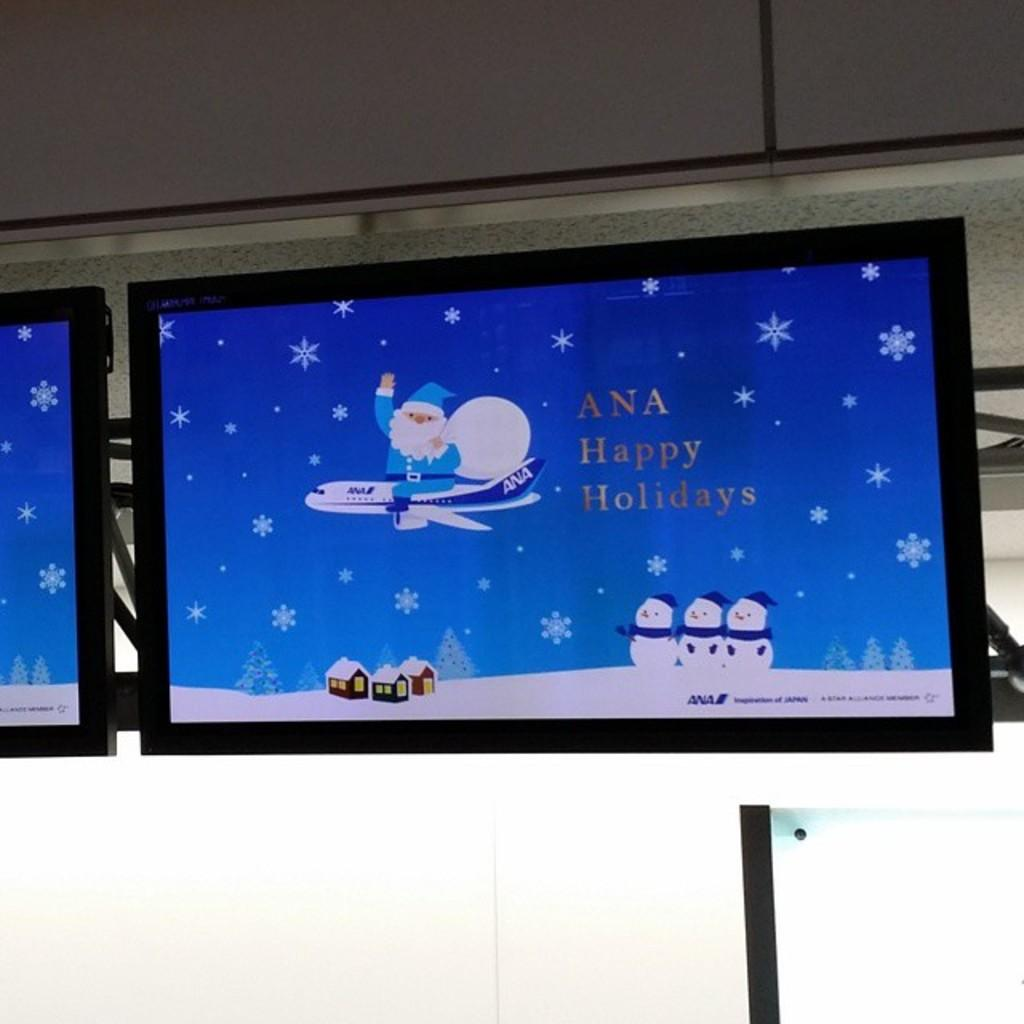<image>
Give a short and clear explanation of the subsequent image. a screen with Happy Holidays written on it 